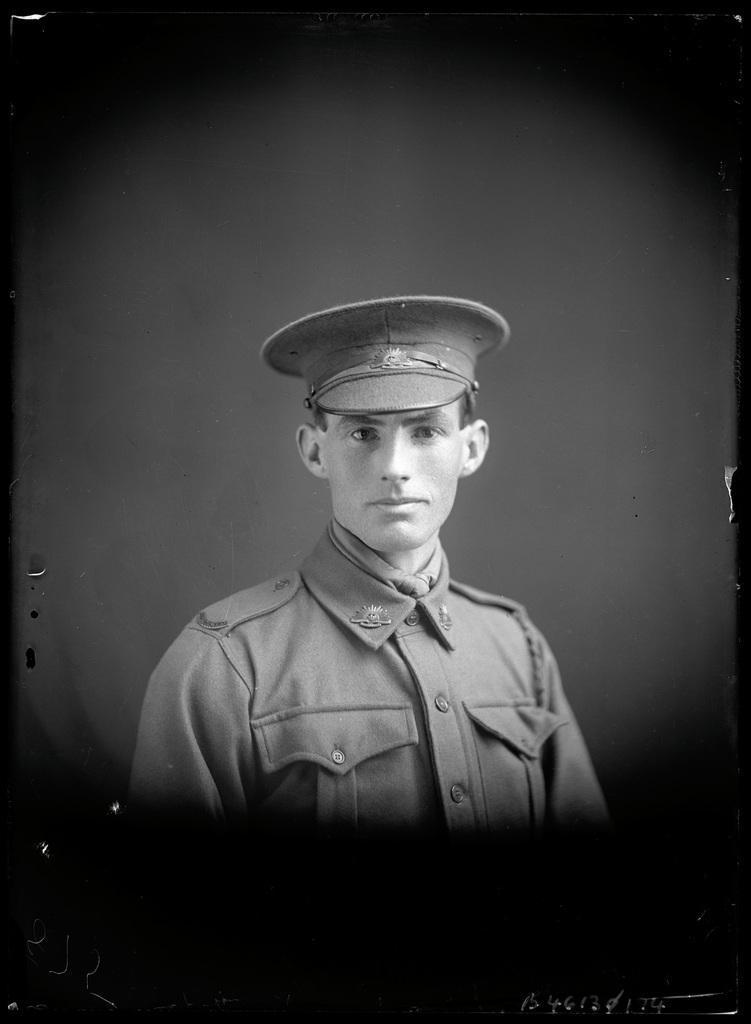Describe this image in one or two sentences. In this picture we can see a man wore a cap and smiling and in the background it is dark. 